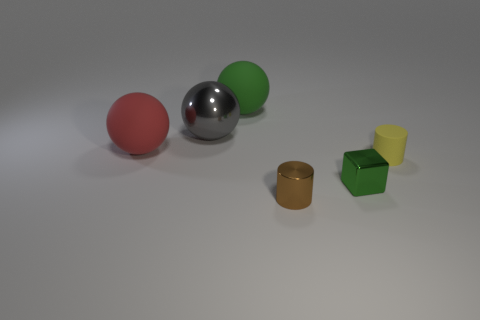Subtract all red matte spheres. How many spheres are left? 2 Add 1 tiny yellow cylinders. How many objects exist? 7 Subtract all gray spheres. How many spheres are left? 2 Subtract all cubes. How many objects are left? 5 Add 3 small brown metallic cylinders. How many small brown metallic cylinders are left? 4 Add 4 small brown cylinders. How many small brown cylinders exist? 5 Subtract 0 brown spheres. How many objects are left? 6 Subtract all red cylinders. Subtract all yellow cubes. How many cylinders are left? 2 Subtract all large gray spheres. Subtract all yellow matte cylinders. How many objects are left? 4 